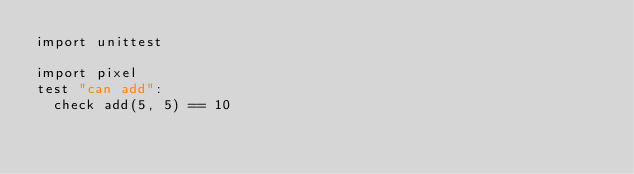Convert code to text. <code><loc_0><loc_0><loc_500><loc_500><_Nim_>import unittest

import pixel
test "can add":
  check add(5, 5) == 10
</code> 